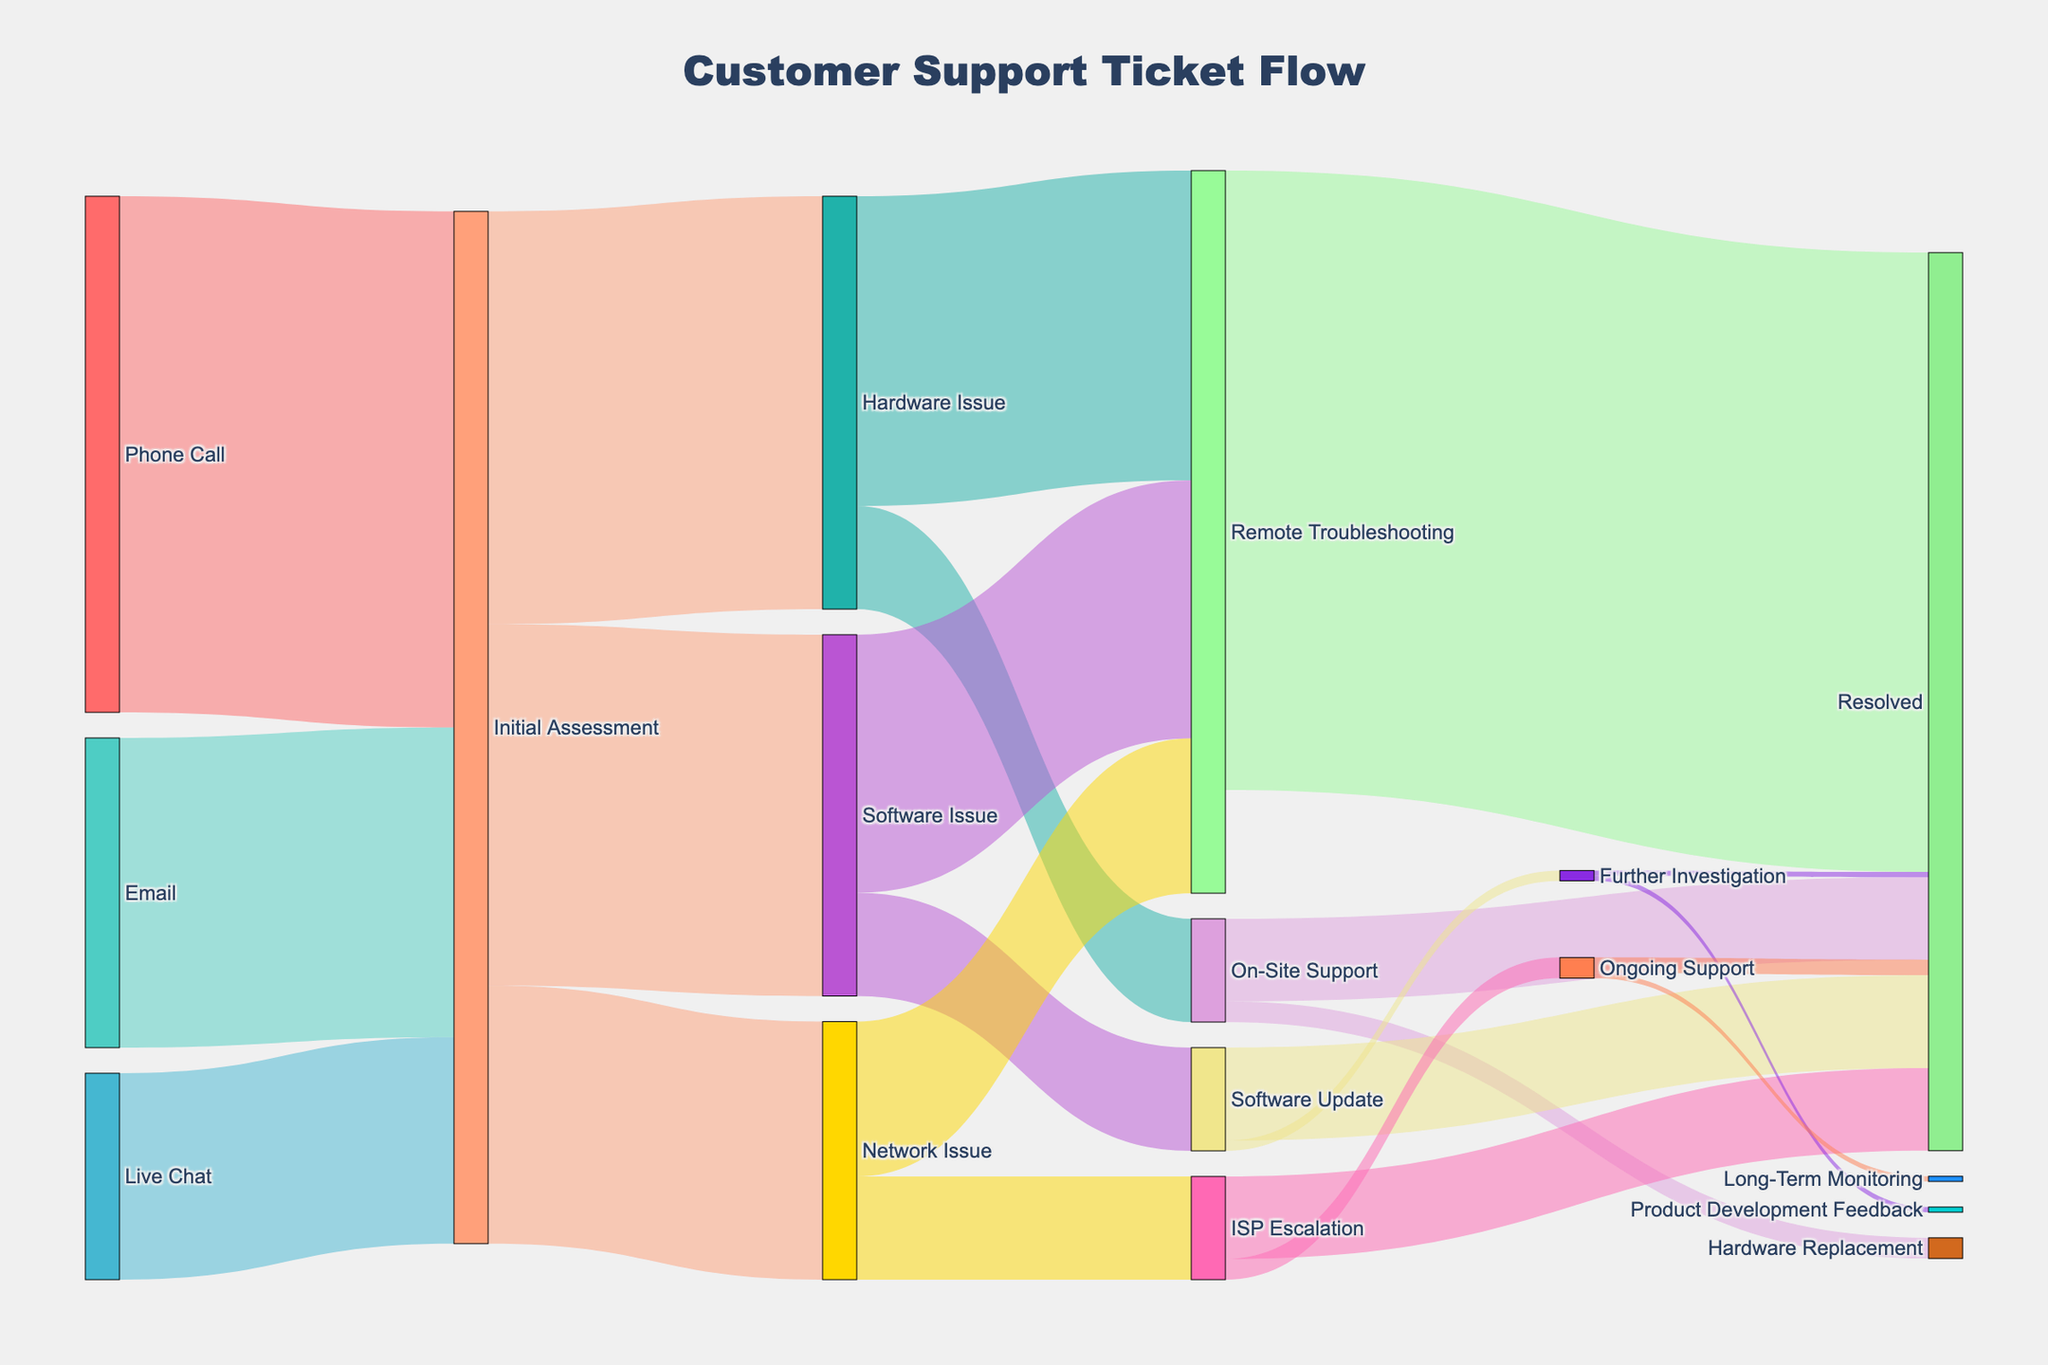what is the title of the figure? The title is displayed at the top center of the plot and reads, "Customer Support Ticket Flow".
Answer: Customer Support Ticket Flow which channel has the highest initial contact volume? Observing the first nodes for each channel, "Phone Call" clearly has the largest flow value of 500 compared to other channels.
Answer: Phone Call how many tickets result in "On-Site Support"? Summing values flowing into "On-Site Support" from the diagram, we get 100 from "Hardware Issue". Thus, a total of 100 tickets.
Answer: 100 which resolution type handled the most tickets? The flow leading to "Resolved" is the highest with values 600 (Remote Troubleshooting), 80 (On-Site Support), and other small amounts summing to a total of 600+80+90+5+80+15 = 870.
Answer: Resolved what's the combined ticket volume at "Initial Assessment"? The total incoming flow into "Initial Assessment" is from Phone Call (500), Email (300), and Live Chat (200), summing up to 1000.
Answer: 1000 compare the ticket volume from "Email" and "Live Chat" at the initial contact stage. which is higher and by how much? Email has 300 tickets, and Live Chat has 200 tickets. Email has 100 more tickets compared to Live Chat.
Answer: Email by 100 if the sum of "Software Issue" tickets resolved solely through "Remote Troubleshooting" and "Software Update" is computed, what is the total? From the diagram, Remote Troubleshooting resolves 250 and Software Update resolves 100, resulting in a combined total of 250+100 = 350 tickets.
Answer: 350 how many tickets handled by "ISP Escalation" remain unresolved and what's the proportion out of the tickets handled by ISP Escalation? Unresolved tickets are "Ongoing Support" (20). ISP Escalation handles 100 tickets. Proportion is 20/100 = 0.2 or 20%.
Answer: 20% what percentage of "Remote Troubleshooting" leads to a resolution? 600 of the 300+250+150 = 700 tickets at "Remote Troubleshooting" lead to a resolution, giving a percentage of (600/700)*100 = ~85.71%.
Answer: ~85.71% how many tickets classified as "Further Investigation" were reported back as "Product Development Feedback"? The flow to "Product Development Feedback" from "Further Investigation" in the diagram is 5 tickets indicating all of the tickets in that segment.
Answer: 5 